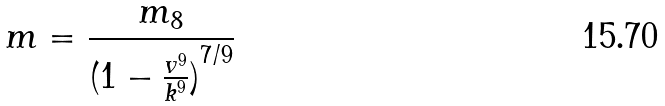Convert formula to latex. <formula><loc_0><loc_0><loc_500><loc_500>m = \frac { m _ { 8 } } { ( { 1 - \frac { v ^ { 9 } } { k ^ { 9 } } ) } ^ { 7 / 9 } }</formula> 